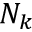Convert formula to latex. <formula><loc_0><loc_0><loc_500><loc_500>N _ { k }</formula> 